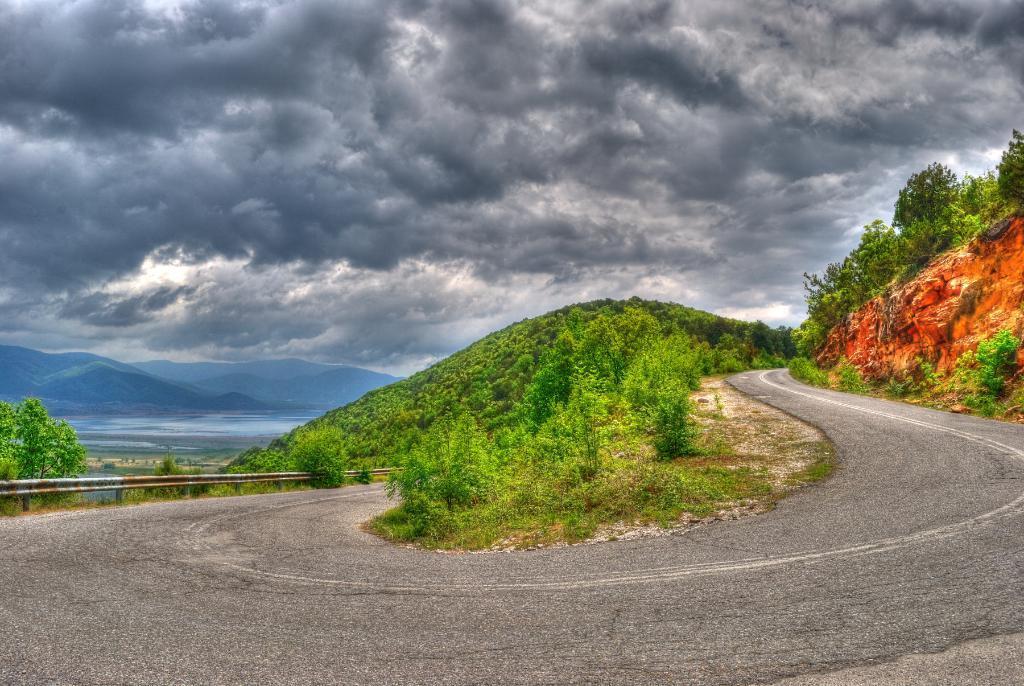Describe this image in one or two sentences. A steep curve of a road with a barrier. There are small plants beside the road. There are some hills and a water body in the background. The sky is clouded. 